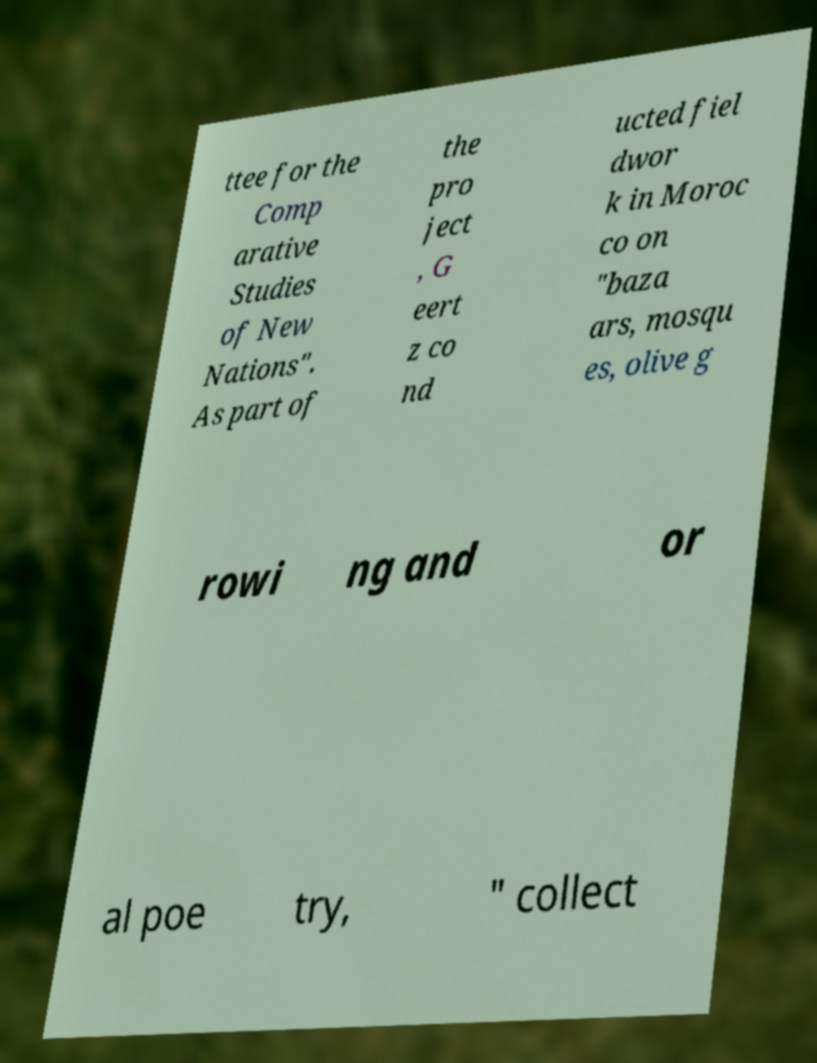Please read and relay the text visible in this image. What does it say? ttee for the Comp arative Studies of New Nations". As part of the pro ject , G eert z co nd ucted fiel dwor k in Moroc co on "baza ars, mosqu es, olive g rowi ng and or al poe try, " collect 